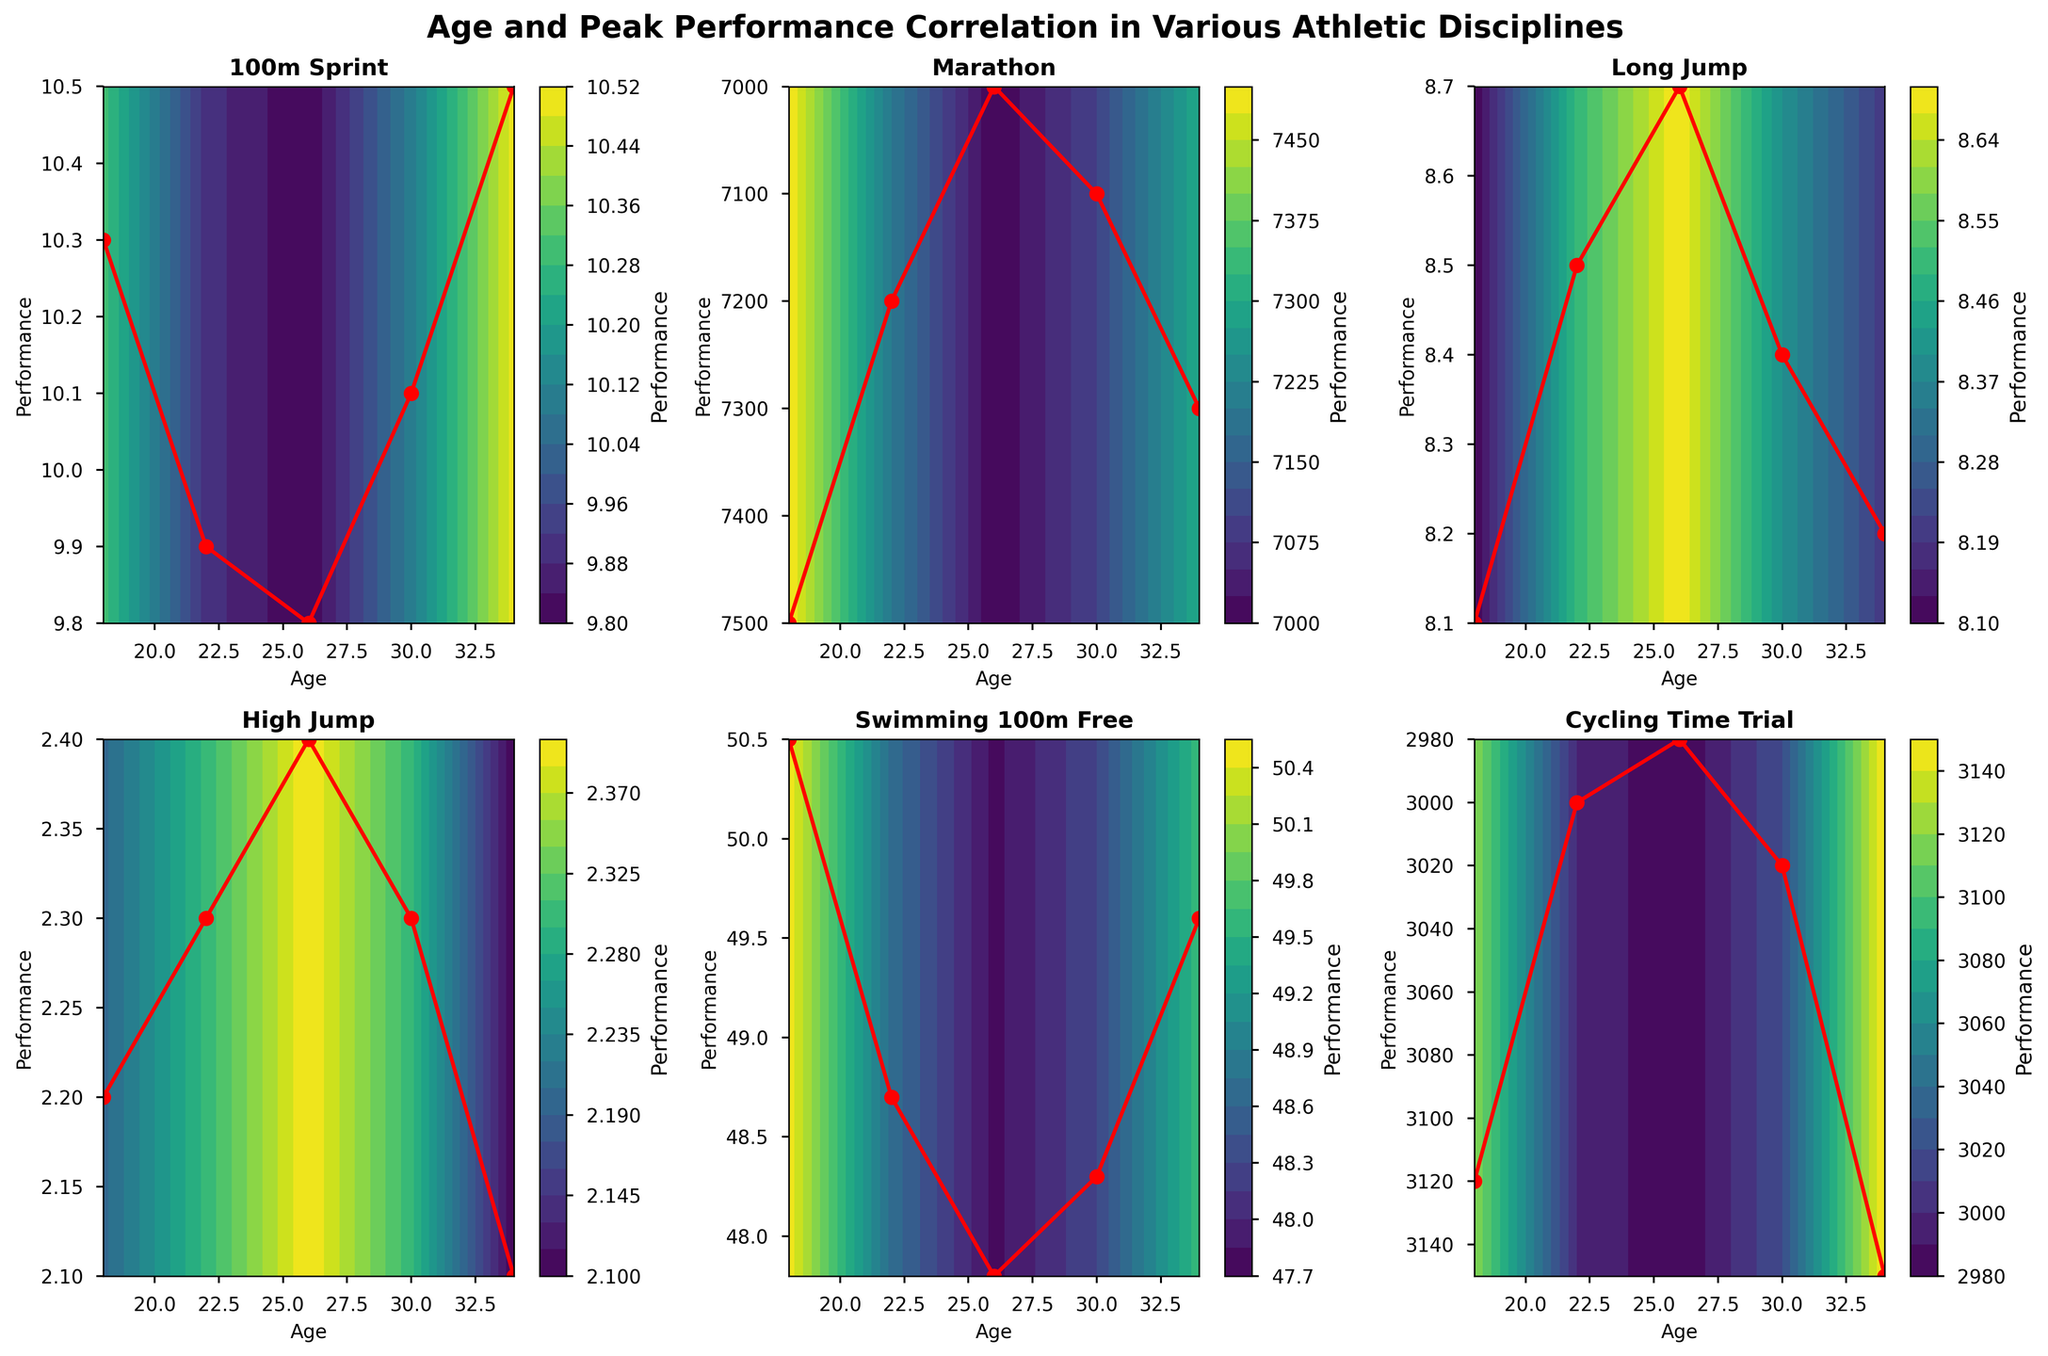How many disciplines are displayed in this figure? The figure contains a 2x3 grid of subplots. Counting each unique subplot title, there are six distinct disciplines shown.
Answer: Six What is the performance range for the 100m Sprint in this figure? By examining the y-axis of the 100m Sprint subplot, the performance values range from 9.8 to 10.5 seconds.
Answer: 9.8 to 10.5 seconds Which discipline shows the highest peak performance at age 26? To find this, look at the performance values for each discipline at age 26. The 100m Sprint has the highest peak performance at age 26 with a performance value of 9.8 seconds.
Answer: 100m Sprint How does the age-related performance trend differ between the Marathon and the 100m Sprint? In the Marathon subplot, performance improves (time decreases) from age 18 to 26 and then worsens slightly. In contrast, in the 100m Sprint, performance improves until age 26 and then declines more noticeably.
Answer: Marathon improves and then slightly worsens; 100m Sprint improves and then noticeably declines For which disciplines does performance decrease after age 30? Examine the performance trends for each discipline after age 30. The 100m Sprint, Long Jump, High Jump, and Swimming 100m Free all show a performance decrease after age 30.
Answer: 100m Sprint, Long Jump, High Jump, Swimming 100m Free Which discipline has the least variation in performance with age? To determine this, compare the range (difference between the maximum and minimum values) of performance for each discipline's y-axis. The High Jump has the least variation in performance with age.
Answer: High Jump What does the color intensity in the contour plots represent? The color intensity in the contour plots represents the performance levels, with darker shades indicating higher performance values.
Answer: Performance levels Between what ages does the Cycling Time Trial performance improve? From the Cycling Time Trial subplot, performance improves from age 18 to 26, as indicated by decreasing times.
Answer: From 18 to 26 Is there a discipline where performance remains relatively stable across the ages displayed? By examining each subplot, the High Jump shows relatively stable performance values across the ages compared to other disciplines.
Answer: High Jump Are there any disciplines where performance increases (e.g., time decreases, distance increases) after age 30? Look for a rise in performance values after age 30 in any subplot. The Marathon shows a minor increase in performance.
Answer: Marathon 